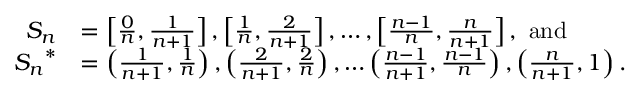<formula> <loc_0><loc_0><loc_500><loc_500>\begin{array} { r l } { S _ { n } } & { = \left [ \frac { 0 } { n } , \frac { 1 } n + 1 } \right ] , \left [ \frac { 1 } { n } , \frac { 2 } { n + 1 } \right ] , \dots , \left [ \frac { n - 1 } n , \frac { n } n + 1 } \right ] , a n d } \\ { { S _ { n } } ^ { * } } & { = \left ( \frac { 1 } { n + 1 } , \frac { 1 } { n } \right ) , \left ( \frac { 2 } { n + 1 } , \frac { 2 } { n } \right ) , \dots \left ( \frac { n - 1 } { n + 1 } , \frac { n - 1 } { n } \right ) , \left ( \frac { n } { n + 1 } , 1 \right ) . } \end{array}</formula> 